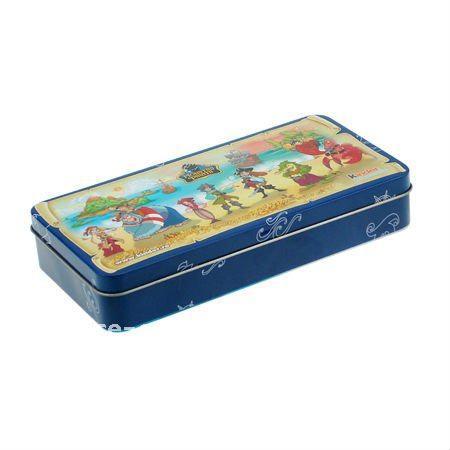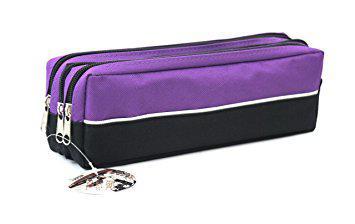The first image is the image on the left, the second image is the image on the right. Given the left and right images, does the statement "One case is solid color and rectangular with rounded edges, and has two zipper pulls on top to zip the case open, and the other case features a bright warm color." hold true? Answer yes or no. No. The first image is the image on the left, the second image is the image on the right. Considering the images on both sides, is "Two pencil cases with top zippers are different sizes and only one has a visible tag affixed." valid? Answer yes or no. No. 